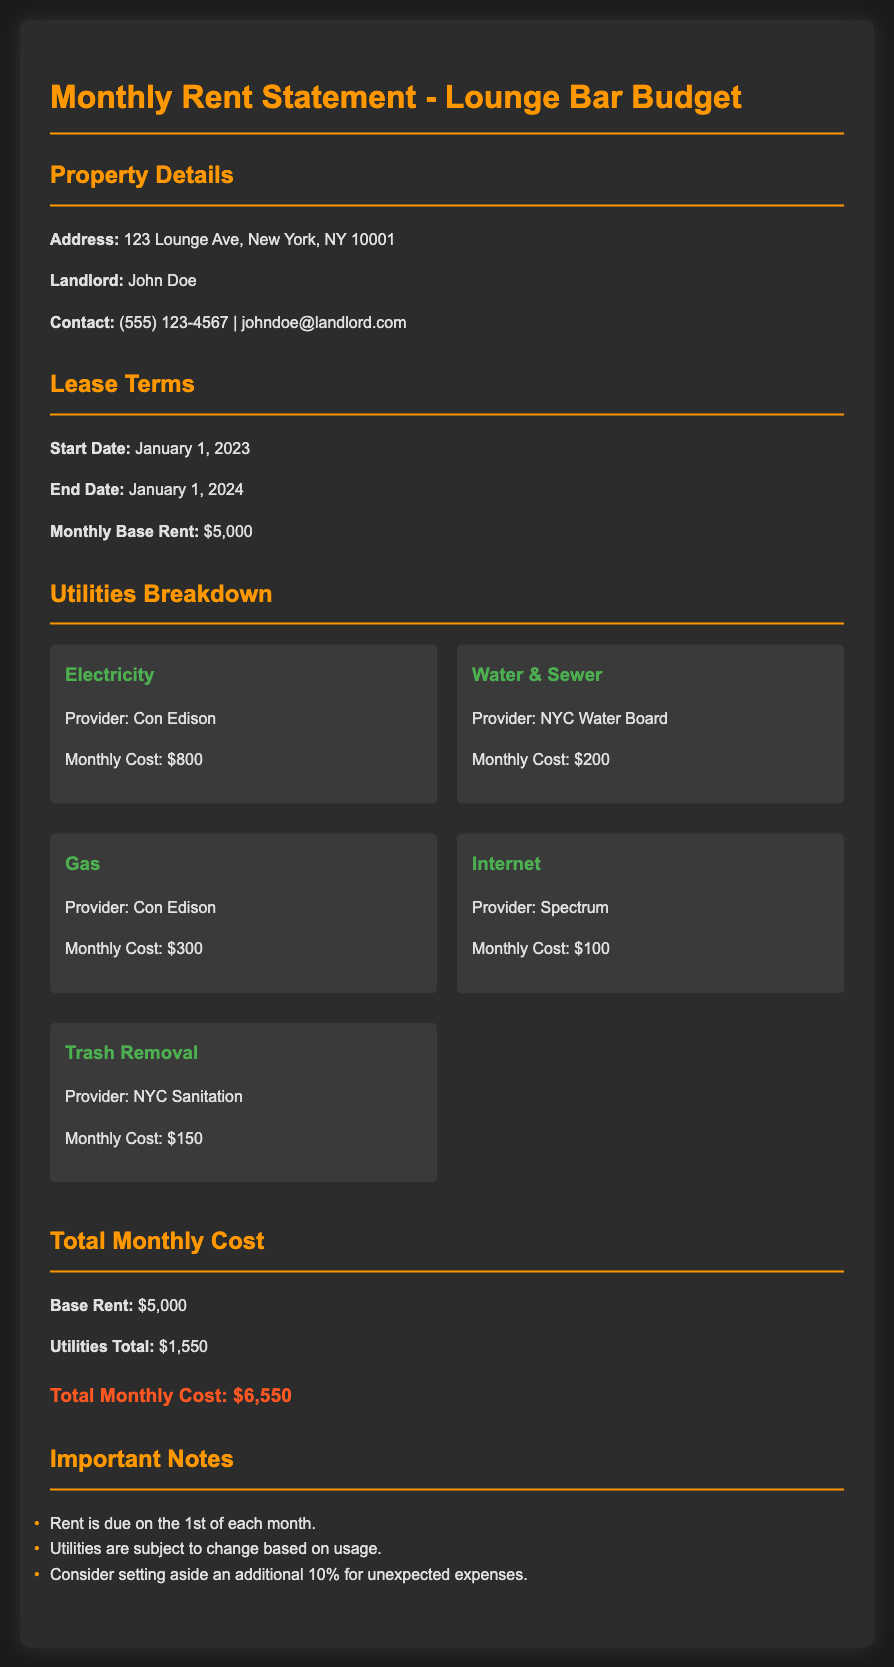What is the address of the lounge bar? The document specifies the address of the lounge bar as 123 Lounge Ave, New York, NY 10001.
Answer: 123 Lounge Ave, New York, NY 10001 Who is the landlord? The document lists John Doe as the landlord for the property.
Answer: John Doe What is the monthly base rent? The document states that the monthly base rent is $5,000.
Answer: $5,000 How much does electricity cost per month? The document indicates that the monthly cost for electricity is $800.
Answer: $800 What is the total monthly cost? The total monthly cost is the sum of the base rent and utilities, totaling $6,550.
Answer: $6,550 How many utilities are included in the breakdown? There are five utilities detailed in the document as part of the breakdown.
Answer: 5 What is the provider for internet service? The document names Spectrum as the provider for internet service.
Answer: Spectrum When is rent due? The document mentions that rent is due on the 1st of each month.
Answer: 1st of each month What percentage should be set aside for unexpected expenses? The document advises setting aside an additional 10% for unexpected expenses.
Answer: 10% 